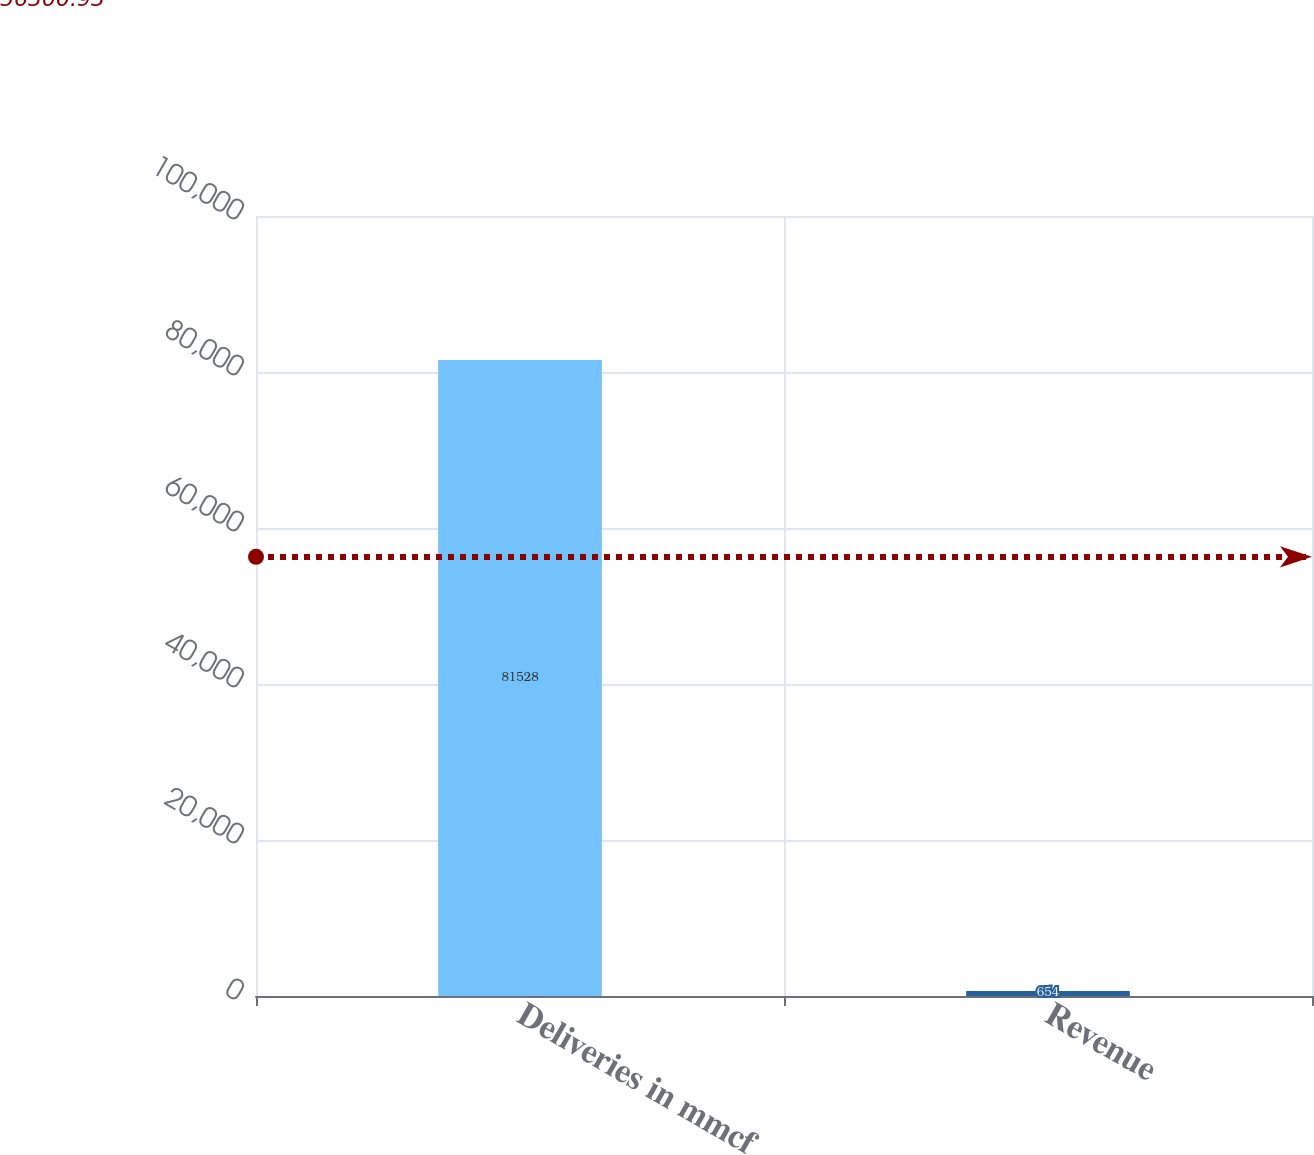Convert chart to OTSL. <chart><loc_0><loc_0><loc_500><loc_500><bar_chart><fcel>Deliveries in mmcf<fcel>Revenue<nl><fcel>81528<fcel>654<nl></chart> 